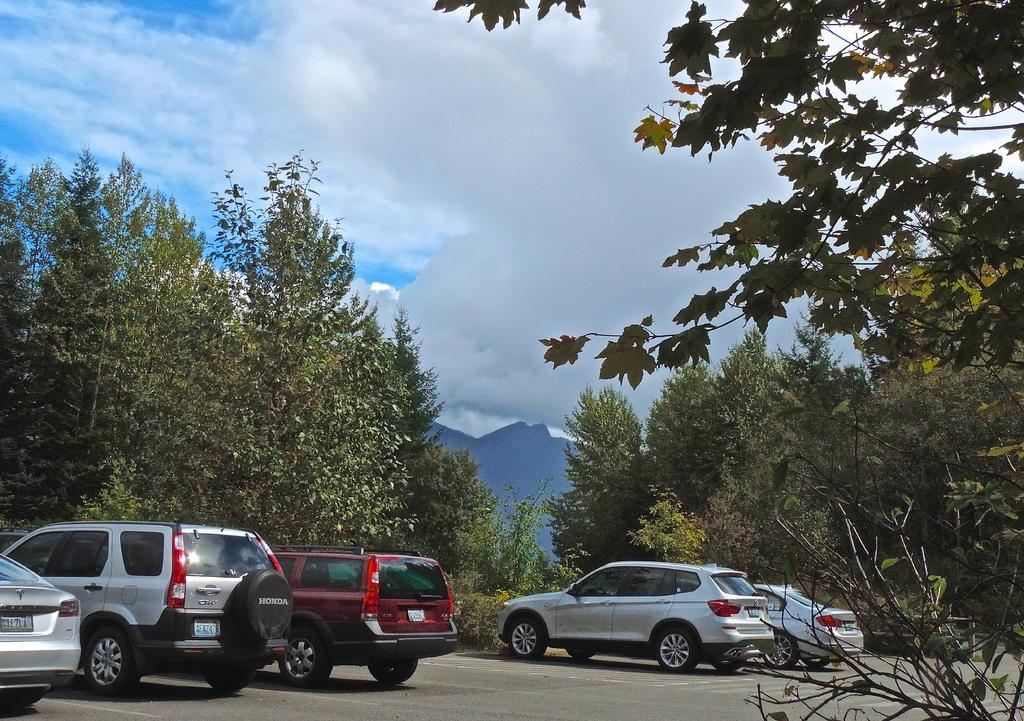What can be seen on the road at the bottom of the image? There are cars parked on the road at the bottom of the image. What type of vegetation is present in the image? There are trees in the image. What is the condition of the sky in the image? The sky is cloudy at the top of the image. Is there a market visible in the image? There is no mention of a market in the provided facts, so it cannot be determined if one is present in the image. What is the tendency of the moon in the image? The moon is not mentioned in the provided facts, so it cannot be determined if it is present or its tendency in the image. 